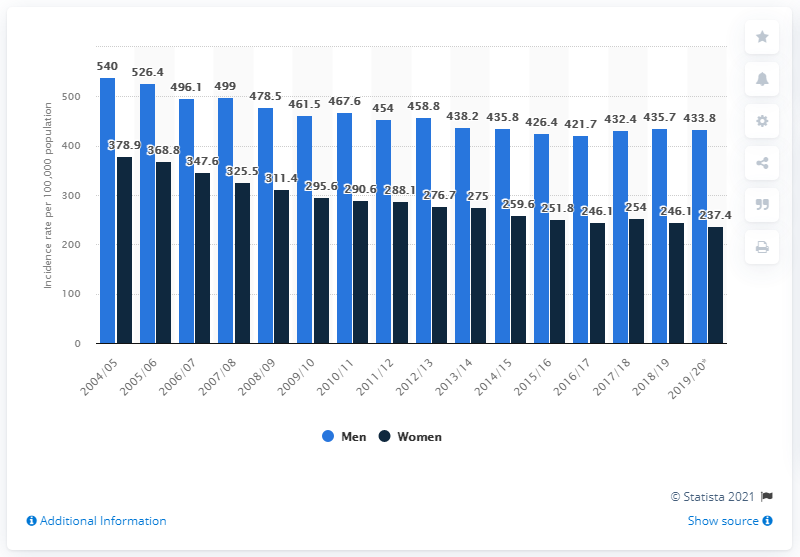Identify some key points in this picture. The incidence rate for women in Scotland in 2019/20 was 237.4 per 100,000 population. In 2004/05, the rate of coronary heart disease per 100,000 population in Scotland was measured. In the 2019/2020 fiscal year, the incidence rate for men in Scotland was 433.8 cases per 100,000 population. 